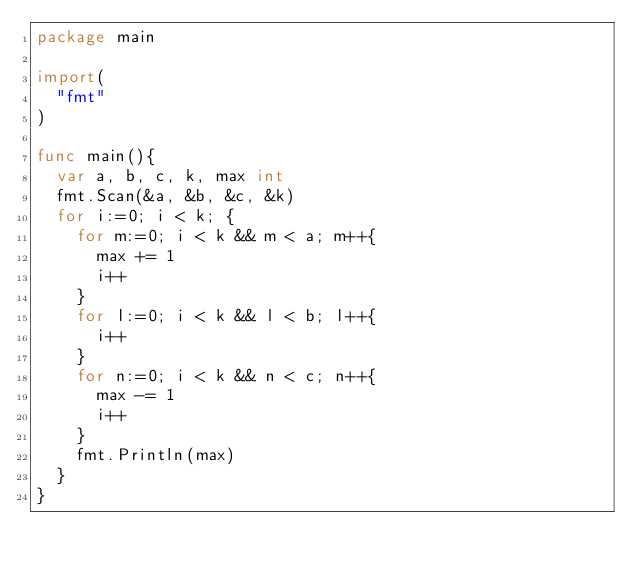<code> <loc_0><loc_0><loc_500><loc_500><_Go_>package main

import(
	"fmt"
)

func main(){
	var a, b, c, k, max int
	fmt.Scan(&a, &b, &c, &k)
	for i:=0; i < k; {
		for m:=0; i < k && m < a; m++{
			max += 1
			i++
		}
		for l:=0; i < k && l < b; l++{
			i++
		}
		for n:=0; i < k && n < c; n++{
			max -= 1
			i++
		}	
		fmt.Println(max)
	}
}</code> 